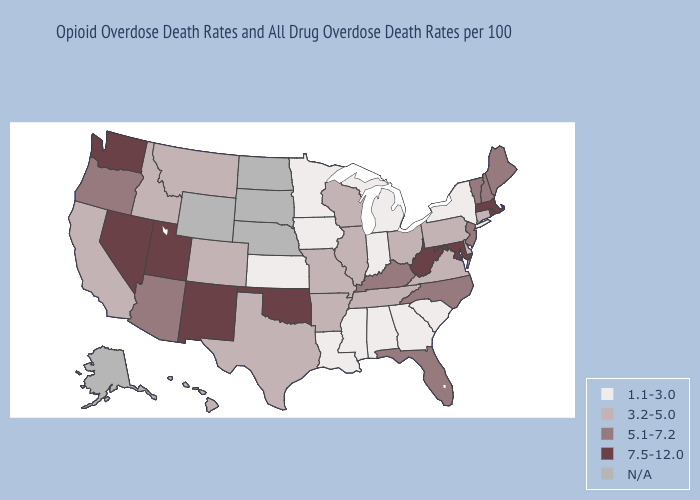Name the states that have a value in the range N/A?
Quick response, please. Alaska, Nebraska, North Dakota, South Dakota, Wyoming. What is the lowest value in the USA?
Short answer required. 1.1-3.0. What is the highest value in states that border Alabama?
Concise answer only. 5.1-7.2. What is the lowest value in the USA?
Give a very brief answer. 1.1-3.0. Which states have the highest value in the USA?
Give a very brief answer. Maryland, Massachusetts, Nevada, New Mexico, Oklahoma, Rhode Island, Utah, Washington, West Virginia. What is the value of Ohio?
Give a very brief answer. 3.2-5.0. Name the states that have a value in the range 3.2-5.0?
Answer briefly. Arkansas, California, Colorado, Connecticut, Delaware, Hawaii, Idaho, Illinois, Missouri, Montana, Ohio, Pennsylvania, Tennessee, Texas, Virginia, Wisconsin. What is the highest value in the South ?
Short answer required. 7.5-12.0. Name the states that have a value in the range N/A?
Give a very brief answer. Alaska, Nebraska, North Dakota, South Dakota, Wyoming. Does Minnesota have the lowest value in the USA?
Short answer required. Yes. Among the states that border Delaware , which have the highest value?
Answer briefly. Maryland. Does Indiana have the highest value in the MidWest?
Concise answer only. No. What is the value of North Dakota?
Short answer required. N/A. Among the states that border Florida , which have the highest value?
Quick response, please. Alabama, Georgia. 